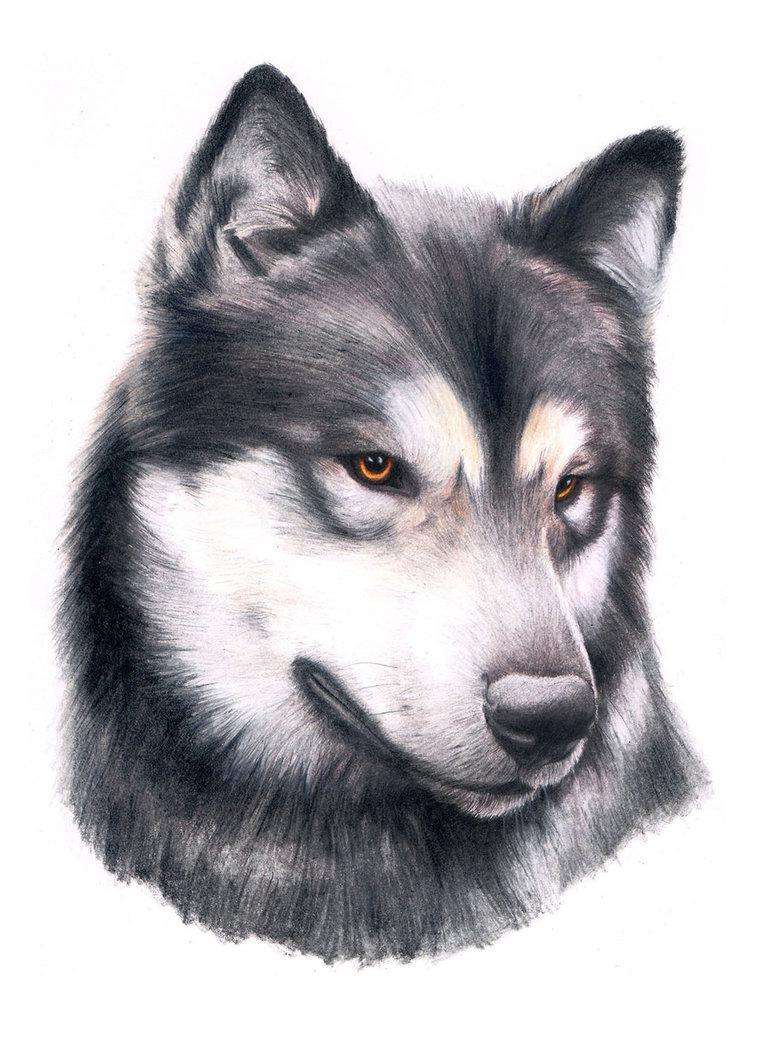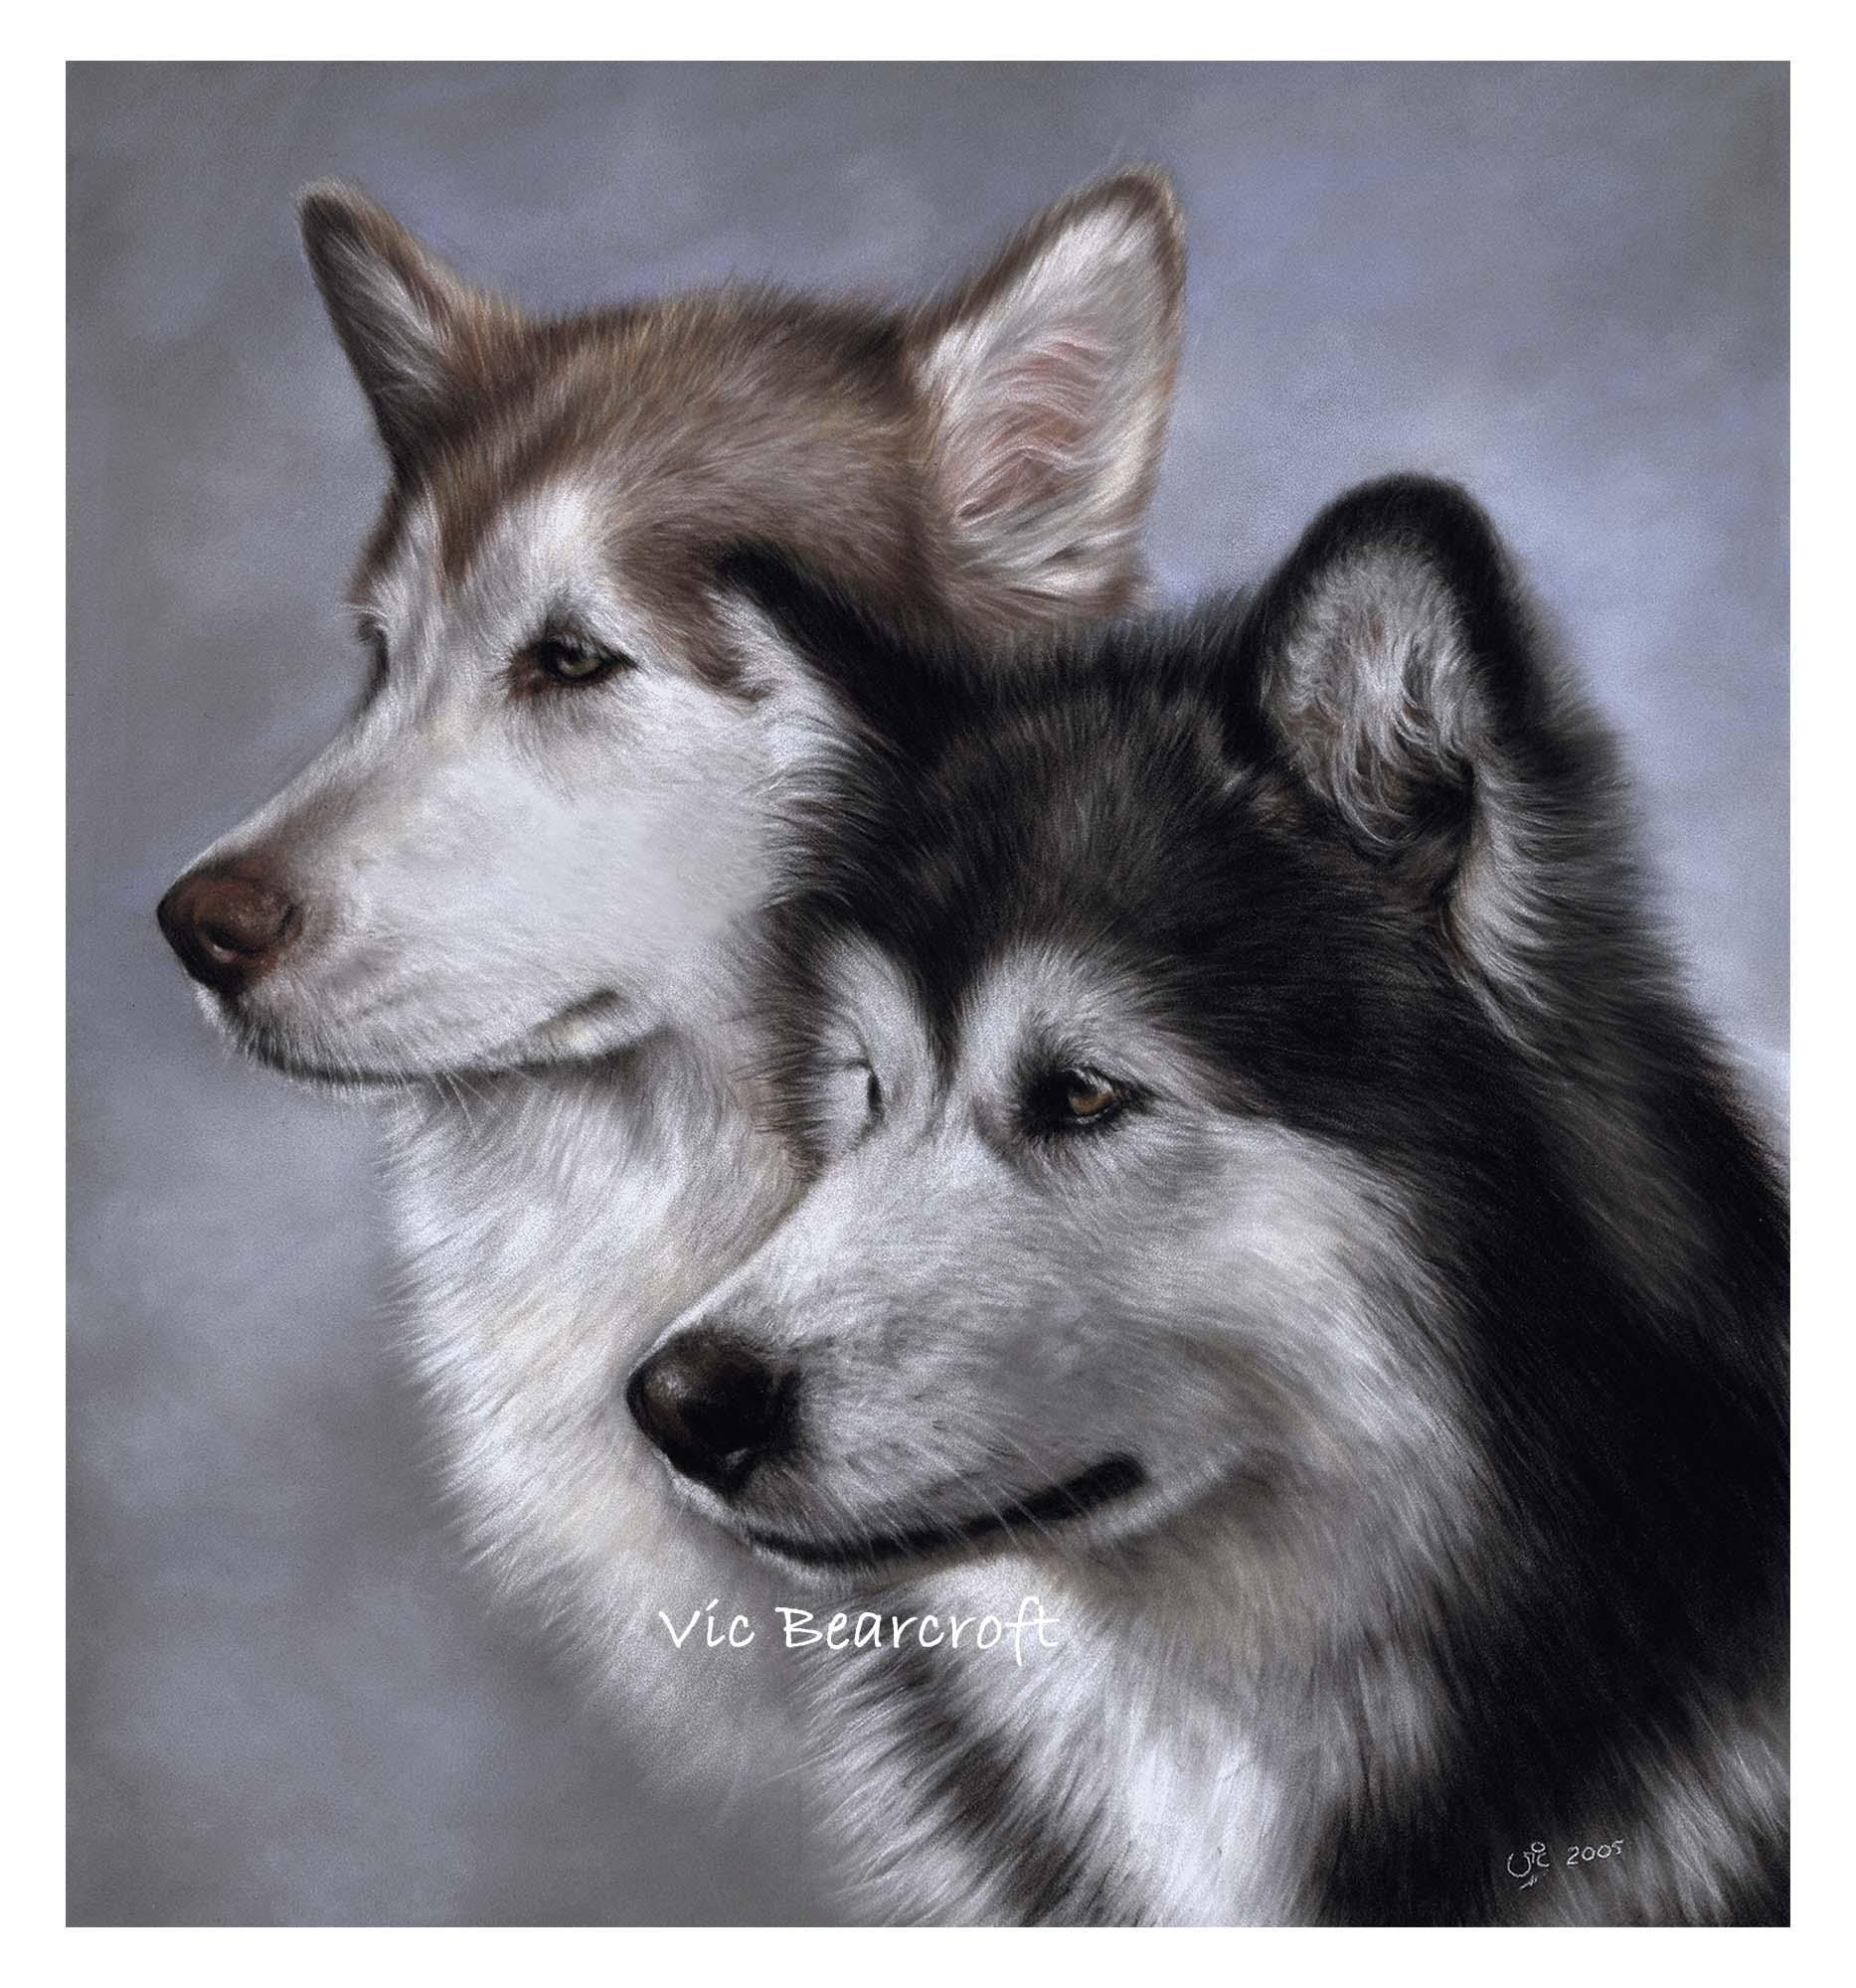The first image is the image on the left, the second image is the image on the right. For the images displayed, is the sentence "The right image features a dog with its head and body angled leftward and its tongue hanging out." factually correct? Answer yes or no. No. The first image is the image on the left, the second image is the image on the right. Given the left and right images, does the statement "In one image the head and paws of an Alaskan Malamute dog are depicted." hold true? Answer yes or no. No. 